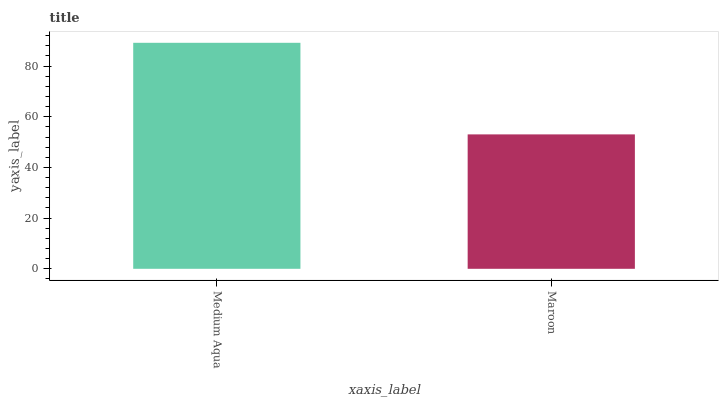Is Maroon the minimum?
Answer yes or no. Yes. Is Medium Aqua the maximum?
Answer yes or no. Yes. Is Maroon the maximum?
Answer yes or no. No. Is Medium Aqua greater than Maroon?
Answer yes or no. Yes. Is Maroon less than Medium Aqua?
Answer yes or no. Yes. Is Maroon greater than Medium Aqua?
Answer yes or no. No. Is Medium Aqua less than Maroon?
Answer yes or no. No. Is Medium Aqua the high median?
Answer yes or no. Yes. Is Maroon the low median?
Answer yes or no. Yes. Is Maroon the high median?
Answer yes or no. No. Is Medium Aqua the low median?
Answer yes or no. No. 